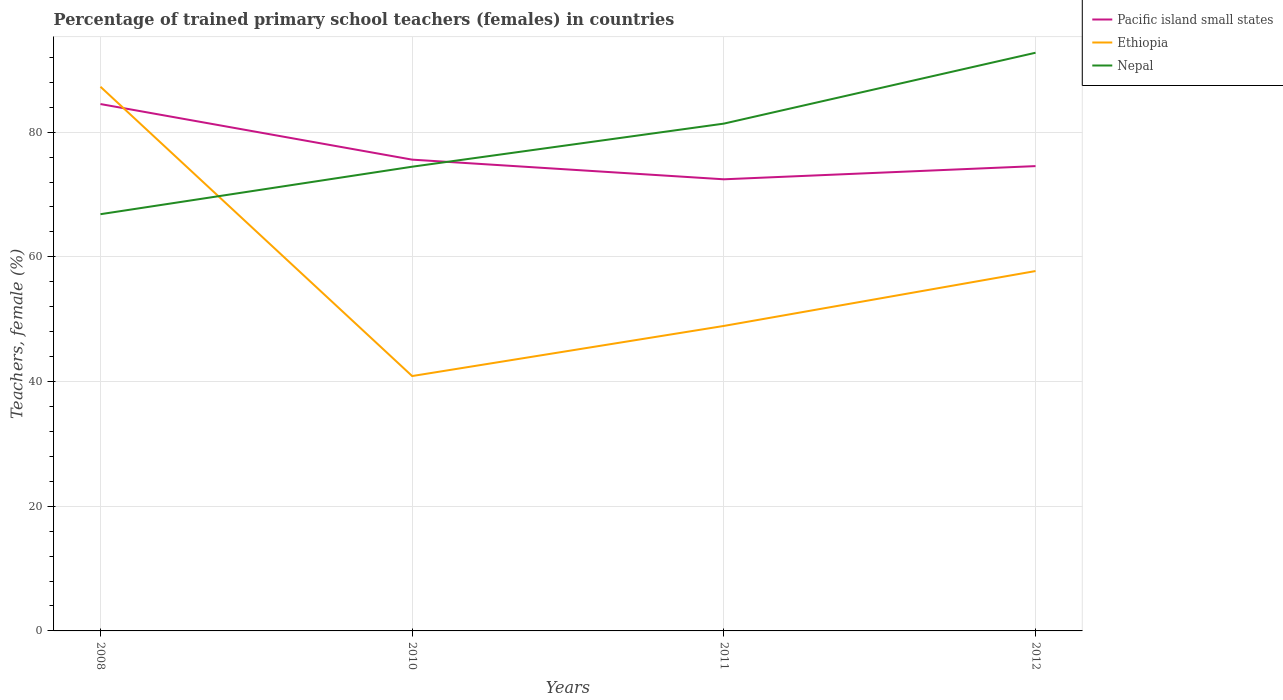How many different coloured lines are there?
Keep it short and to the point. 3. Is the number of lines equal to the number of legend labels?
Your response must be concise. Yes. Across all years, what is the maximum percentage of trained primary school teachers (females) in Nepal?
Ensure brevity in your answer.  66.84. What is the total percentage of trained primary school teachers (females) in Nepal in the graph?
Your answer should be compact. -25.9. What is the difference between the highest and the second highest percentage of trained primary school teachers (females) in Ethiopia?
Ensure brevity in your answer.  46.4. What is the difference between the highest and the lowest percentage of trained primary school teachers (females) in Nepal?
Offer a terse response. 2. Is the percentage of trained primary school teachers (females) in Nepal strictly greater than the percentage of trained primary school teachers (females) in Ethiopia over the years?
Your answer should be very brief. No. Are the values on the major ticks of Y-axis written in scientific E-notation?
Provide a succinct answer. No. Does the graph contain grids?
Offer a terse response. Yes. How many legend labels are there?
Your answer should be very brief. 3. What is the title of the graph?
Your answer should be compact. Percentage of trained primary school teachers (females) in countries. Does "Rwanda" appear as one of the legend labels in the graph?
Provide a succinct answer. No. What is the label or title of the Y-axis?
Provide a succinct answer. Teachers, female (%). What is the Teachers, female (%) in Pacific island small states in 2008?
Your response must be concise. 84.51. What is the Teachers, female (%) in Ethiopia in 2008?
Give a very brief answer. 87.28. What is the Teachers, female (%) of Nepal in 2008?
Your answer should be very brief. 66.84. What is the Teachers, female (%) in Pacific island small states in 2010?
Your answer should be compact. 75.59. What is the Teachers, female (%) in Ethiopia in 2010?
Offer a very short reply. 40.88. What is the Teachers, female (%) in Nepal in 2010?
Provide a succinct answer. 74.46. What is the Teachers, female (%) in Pacific island small states in 2011?
Ensure brevity in your answer.  72.44. What is the Teachers, female (%) in Ethiopia in 2011?
Keep it short and to the point. 48.92. What is the Teachers, female (%) in Nepal in 2011?
Give a very brief answer. 81.37. What is the Teachers, female (%) of Pacific island small states in 2012?
Give a very brief answer. 74.55. What is the Teachers, female (%) of Ethiopia in 2012?
Offer a very short reply. 57.72. What is the Teachers, female (%) in Nepal in 2012?
Keep it short and to the point. 92.74. Across all years, what is the maximum Teachers, female (%) in Pacific island small states?
Provide a succinct answer. 84.51. Across all years, what is the maximum Teachers, female (%) in Ethiopia?
Ensure brevity in your answer.  87.28. Across all years, what is the maximum Teachers, female (%) in Nepal?
Your answer should be compact. 92.74. Across all years, what is the minimum Teachers, female (%) in Pacific island small states?
Offer a very short reply. 72.44. Across all years, what is the minimum Teachers, female (%) in Ethiopia?
Provide a succinct answer. 40.88. Across all years, what is the minimum Teachers, female (%) in Nepal?
Provide a succinct answer. 66.84. What is the total Teachers, female (%) of Pacific island small states in the graph?
Make the answer very short. 307.09. What is the total Teachers, female (%) of Ethiopia in the graph?
Offer a terse response. 234.81. What is the total Teachers, female (%) of Nepal in the graph?
Provide a succinct answer. 315.41. What is the difference between the Teachers, female (%) in Pacific island small states in 2008 and that in 2010?
Give a very brief answer. 8.92. What is the difference between the Teachers, female (%) in Ethiopia in 2008 and that in 2010?
Offer a terse response. 46.4. What is the difference between the Teachers, female (%) in Nepal in 2008 and that in 2010?
Give a very brief answer. -7.62. What is the difference between the Teachers, female (%) in Pacific island small states in 2008 and that in 2011?
Offer a terse response. 12.07. What is the difference between the Teachers, female (%) of Ethiopia in 2008 and that in 2011?
Provide a succinct answer. 38.37. What is the difference between the Teachers, female (%) of Nepal in 2008 and that in 2011?
Give a very brief answer. -14.53. What is the difference between the Teachers, female (%) in Pacific island small states in 2008 and that in 2012?
Your response must be concise. 9.95. What is the difference between the Teachers, female (%) of Ethiopia in 2008 and that in 2012?
Offer a terse response. 29.56. What is the difference between the Teachers, female (%) in Nepal in 2008 and that in 2012?
Keep it short and to the point. -25.9. What is the difference between the Teachers, female (%) of Pacific island small states in 2010 and that in 2011?
Your answer should be very brief. 3.15. What is the difference between the Teachers, female (%) in Ethiopia in 2010 and that in 2011?
Keep it short and to the point. -8.04. What is the difference between the Teachers, female (%) of Nepal in 2010 and that in 2011?
Offer a very short reply. -6.91. What is the difference between the Teachers, female (%) of Pacific island small states in 2010 and that in 2012?
Offer a terse response. 1.04. What is the difference between the Teachers, female (%) of Ethiopia in 2010 and that in 2012?
Provide a short and direct response. -16.84. What is the difference between the Teachers, female (%) of Nepal in 2010 and that in 2012?
Give a very brief answer. -18.28. What is the difference between the Teachers, female (%) of Pacific island small states in 2011 and that in 2012?
Your answer should be very brief. -2.12. What is the difference between the Teachers, female (%) of Ethiopia in 2011 and that in 2012?
Provide a short and direct response. -8.8. What is the difference between the Teachers, female (%) of Nepal in 2011 and that in 2012?
Keep it short and to the point. -11.37. What is the difference between the Teachers, female (%) in Pacific island small states in 2008 and the Teachers, female (%) in Ethiopia in 2010?
Your answer should be compact. 43.63. What is the difference between the Teachers, female (%) of Pacific island small states in 2008 and the Teachers, female (%) of Nepal in 2010?
Provide a succinct answer. 10.05. What is the difference between the Teachers, female (%) of Ethiopia in 2008 and the Teachers, female (%) of Nepal in 2010?
Offer a very short reply. 12.83. What is the difference between the Teachers, female (%) in Pacific island small states in 2008 and the Teachers, female (%) in Ethiopia in 2011?
Offer a terse response. 35.59. What is the difference between the Teachers, female (%) of Pacific island small states in 2008 and the Teachers, female (%) of Nepal in 2011?
Give a very brief answer. 3.14. What is the difference between the Teachers, female (%) of Ethiopia in 2008 and the Teachers, female (%) of Nepal in 2011?
Offer a very short reply. 5.91. What is the difference between the Teachers, female (%) in Pacific island small states in 2008 and the Teachers, female (%) in Ethiopia in 2012?
Offer a terse response. 26.79. What is the difference between the Teachers, female (%) in Pacific island small states in 2008 and the Teachers, female (%) in Nepal in 2012?
Offer a very short reply. -8.23. What is the difference between the Teachers, female (%) in Ethiopia in 2008 and the Teachers, female (%) in Nepal in 2012?
Offer a terse response. -5.45. What is the difference between the Teachers, female (%) of Pacific island small states in 2010 and the Teachers, female (%) of Ethiopia in 2011?
Offer a terse response. 26.67. What is the difference between the Teachers, female (%) of Pacific island small states in 2010 and the Teachers, female (%) of Nepal in 2011?
Keep it short and to the point. -5.78. What is the difference between the Teachers, female (%) of Ethiopia in 2010 and the Teachers, female (%) of Nepal in 2011?
Your answer should be very brief. -40.49. What is the difference between the Teachers, female (%) of Pacific island small states in 2010 and the Teachers, female (%) of Ethiopia in 2012?
Your answer should be compact. 17.87. What is the difference between the Teachers, female (%) of Pacific island small states in 2010 and the Teachers, female (%) of Nepal in 2012?
Ensure brevity in your answer.  -17.15. What is the difference between the Teachers, female (%) of Ethiopia in 2010 and the Teachers, female (%) of Nepal in 2012?
Keep it short and to the point. -51.86. What is the difference between the Teachers, female (%) of Pacific island small states in 2011 and the Teachers, female (%) of Ethiopia in 2012?
Provide a short and direct response. 14.72. What is the difference between the Teachers, female (%) in Pacific island small states in 2011 and the Teachers, female (%) in Nepal in 2012?
Provide a short and direct response. -20.3. What is the difference between the Teachers, female (%) of Ethiopia in 2011 and the Teachers, female (%) of Nepal in 2012?
Offer a very short reply. -43.82. What is the average Teachers, female (%) in Pacific island small states per year?
Your answer should be compact. 76.77. What is the average Teachers, female (%) of Ethiopia per year?
Provide a succinct answer. 58.7. What is the average Teachers, female (%) in Nepal per year?
Your answer should be very brief. 78.85. In the year 2008, what is the difference between the Teachers, female (%) in Pacific island small states and Teachers, female (%) in Ethiopia?
Give a very brief answer. -2.78. In the year 2008, what is the difference between the Teachers, female (%) in Pacific island small states and Teachers, female (%) in Nepal?
Offer a very short reply. 17.67. In the year 2008, what is the difference between the Teachers, female (%) of Ethiopia and Teachers, female (%) of Nepal?
Provide a short and direct response. 20.44. In the year 2010, what is the difference between the Teachers, female (%) of Pacific island small states and Teachers, female (%) of Ethiopia?
Your answer should be compact. 34.71. In the year 2010, what is the difference between the Teachers, female (%) of Pacific island small states and Teachers, female (%) of Nepal?
Provide a short and direct response. 1.13. In the year 2010, what is the difference between the Teachers, female (%) of Ethiopia and Teachers, female (%) of Nepal?
Offer a very short reply. -33.58. In the year 2011, what is the difference between the Teachers, female (%) in Pacific island small states and Teachers, female (%) in Ethiopia?
Keep it short and to the point. 23.52. In the year 2011, what is the difference between the Teachers, female (%) in Pacific island small states and Teachers, female (%) in Nepal?
Keep it short and to the point. -8.93. In the year 2011, what is the difference between the Teachers, female (%) of Ethiopia and Teachers, female (%) of Nepal?
Make the answer very short. -32.45. In the year 2012, what is the difference between the Teachers, female (%) in Pacific island small states and Teachers, female (%) in Ethiopia?
Your answer should be very brief. 16.83. In the year 2012, what is the difference between the Teachers, female (%) in Pacific island small states and Teachers, female (%) in Nepal?
Provide a succinct answer. -18.18. In the year 2012, what is the difference between the Teachers, female (%) in Ethiopia and Teachers, female (%) in Nepal?
Keep it short and to the point. -35.02. What is the ratio of the Teachers, female (%) in Pacific island small states in 2008 to that in 2010?
Give a very brief answer. 1.12. What is the ratio of the Teachers, female (%) of Ethiopia in 2008 to that in 2010?
Offer a very short reply. 2.14. What is the ratio of the Teachers, female (%) in Nepal in 2008 to that in 2010?
Your answer should be very brief. 0.9. What is the ratio of the Teachers, female (%) of Pacific island small states in 2008 to that in 2011?
Your answer should be very brief. 1.17. What is the ratio of the Teachers, female (%) of Ethiopia in 2008 to that in 2011?
Your answer should be very brief. 1.78. What is the ratio of the Teachers, female (%) of Nepal in 2008 to that in 2011?
Offer a terse response. 0.82. What is the ratio of the Teachers, female (%) in Pacific island small states in 2008 to that in 2012?
Ensure brevity in your answer.  1.13. What is the ratio of the Teachers, female (%) of Ethiopia in 2008 to that in 2012?
Your response must be concise. 1.51. What is the ratio of the Teachers, female (%) in Nepal in 2008 to that in 2012?
Your answer should be very brief. 0.72. What is the ratio of the Teachers, female (%) in Pacific island small states in 2010 to that in 2011?
Make the answer very short. 1.04. What is the ratio of the Teachers, female (%) of Ethiopia in 2010 to that in 2011?
Your answer should be compact. 0.84. What is the ratio of the Teachers, female (%) of Nepal in 2010 to that in 2011?
Give a very brief answer. 0.92. What is the ratio of the Teachers, female (%) of Pacific island small states in 2010 to that in 2012?
Ensure brevity in your answer.  1.01. What is the ratio of the Teachers, female (%) in Ethiopia in 2010 to that in 2012?
Provide a succinct answer. 0.71. What is the ratio of the Teachers, female (%) in Nepal in 2010 to that in 2012?
Offer a very short reply. 0.8. What is the ratio of the Teachers, female (%) of Pacific island small states in 2011 to that in 2012?
Provide a succinct answer. 0.97. What is the ratio of the Teachers, female (%) in Ethiopia in 2011 to that in 2012?
Your answer should be compact. 0.85. What is the ratio of the Teachers, female (%) of Nepal in 2011 to that in 2012?
Your response must be concise. 0.88. What is the difference between the highest and the second highest Teachers, female (%) of Pacific island small states?
Provide a succinct answer. 8.92. What is the difference between the highest and the second highest Teachers, female (%) of Ethiopia?
Offer a terse response. 29.56. What is the difference between the highest and the second highest Teachers, female (%) of Nepal?
Keep it short and to the point. 11.37. What is the difference between the highest and the lowest Teachers, female (%) in Pacific island small states?
Offer a terse response. 12.07. What is the difference between the highest and the lowest Teachers, female (%) of Ethiopia?
Your response must be concise. 46.4. What is the difference between the highest and the lowest Teachers, female (%) in Nepal?
Offer a terse response. 25.9. 